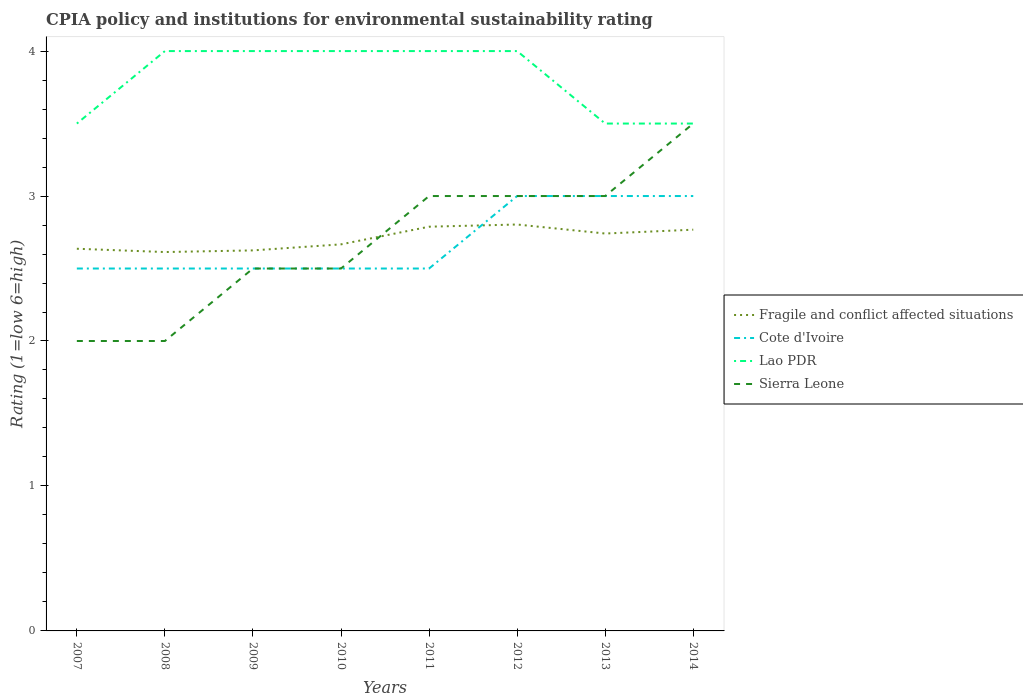Is the number of lines equal to the number of legend labels?
Your answer should be compact. Yes. Across all years, what is the maximum CPIA rating in Fragile and conflict affected situations?
Provide a short and direct response. 2.61. In which year was the CPIA rating in Fragile and conflict affected situations maximum?
Your answer should be compact. 2008. What is the total CPIA rating in Sierra Leone in the graph?
Provide a short and direct response. -0.5. What is the difference between the highest and the second highest CPIA rating in Sierra Leone?
Make the answer very short. 1.5. What is the difference between two consecutive major ticks on the Y-axis?
Offer a very short reply. 1. Are the values on the major ticks of Y-axis written in scientific E-notation?
Ensure brevity in your answer.  No. Does the graph contain any zero values?
Provide a short and direct response. No. Does the graph contain grids?
Offer a very short reply. No. Where does the legend appear in the graph?
Ensure brevity in your answer.  Center right. What is the title of the graph?
Provide a short and direct response. CPIA policy and institutions for environmental sustainability rating. Does "Pacific island small states" appear as one of the legend labels in the graph?
Make the answer very short. No. What is the label or title of the X-axis?
Ensure brevity in your answer.  Years. What is the Rating (1=low 6=high) of Fragile and conflict affected situations in 2007?
Offer a very short reply. 2.64. What is the Rating (1=low 6=high) of Fragile and conflict affected situations in 2008?
Make the answer very short. 2.61. What is the Rating (1=low 6=high) of Cote d'Ivoire in 2008?
Offer a terse response. 2.5. What is the Rating (1=low 6=high) of Lao PDR in 2008?
Provide a short and direct response. 4. What is the Rating (1=low 6=high) in Fragile and conflict affected situations in 2009?
Offer a very short reply. 2.62. What is the Rating (1=low 6=high) of Sierra Leone in 2009?
Offer a very short reply. 2.5. What is the Rating (1=low 6=high) of Fragile and conflict affected situations in 2010?
Offer a very short reply. 2.67. What is the Rating (1=low 6=high) in Fragile and conflict affected situations in 2011?
Your answer should be very brief. 2.79. What is the Rating (1=low 6=high) in Cote d'Ivoire in 2011?
Your response must be concise. 2.5. What is the Rating (1=low 6=high) in Lao PDR in 2011?
Provide a succinct answer. 4. What is the Rating (1=low 6=high) of Fragile and conflict affected situations in 2012?
Offer a very short reply. 2.8. What is the Rating (1=low 6=high) in Sierra Leone in 2012?
Give a very brief answer. 3. What is the Rating (1=low 6=high) of Fragile and conflict affected situations in 2013?
Ensure brevity in your answer.  2.74. What is the Rating (1=low 6=high) in Lao PDR in 2013?
Provide a short and direct response. 3.5. What is the Rating (1=low 6=high) of Sierra Leone in 2013?
Ensure brevity in your answer.  3. What is the Rating (1=low 6=high) in Fragile and conflict affected situations in 2014?
Make the answer very short. 2.77. What is the Rating (1=low 6=high) in Lao PDR in 2014?
Your response must be concise. 3.5. What is the Rating (1=low 6=high) in Sierra Leone in 2014?
Ensure brevity in your answer.  3.5. Across all years, what is the maximum Rating (1=low 6=high) of Fragile and conflict affected situations?
Provide a short and direct response. 2.8. Across all years, what is the maximum Rating (1=low 6=high) of Sierra Leone?
Give a very brief answer. 3.5. Across all years, what is the minimum Rating (1=low 6=high) of Fragile and conflict affected situations?
Provide a short and direct response. 2.61. Across all years, what is the minimum Rating (1=low 6=high) of Lao PDR?
Keep it short and to the point. 3.5. What is the total Rating (1=low 6=high) of Fragile and conflict affected situations in the graph?
Provide a succinct answer. 21.64. What is the total Rating (1=low 6=high) in Cote d'Ivoire in the graph?
Your response must be concise. 21.5. What is the total Rating (1=low 6=high) of Lao PDR in the graph?
Give a very brief answer. 30.5. What is the total Rating (1=low 6=high) in Sierra Leone in the graph?
Give a very brief answer. 21.5. What is the difference between the Rating (1=low 6=high) in Fragile and conflict affected situations in 2007 and that in 2008?
Give a very brief answer. 0.02. What is the difference between the Rating (1=low 6=high) of Lao PDR in 2007 and that in 2008?
Ensure brevity in your answer.  -0.5. What is the difference between the Rating (1=low 6=high) of Sierra Leone in 2007 and that in 2008?
Your answer should be compact. 0. What is the difference between the Rating (1=low 6=high) of Fragile and conflict affected situations in 2007 and that in 2009?
Keep it short and to the point. 0.01. What is the difference between the Rating (1=low 6=high) of Sierra Leone in 2007 and that in 2009?
Your response must be concise. -0.5. What is the difference between the Rating (1=low 6=high) of Fragile and conflict affected situations in 2007 and that in 2010?
Your answer should be compact. -0.03. What is the difference between the Rating (1=low 6=high) in Lao PDR in 2007 and that in 2010?
Keep it short and to the point. -0.5. What is the difference between the Rating (1=low 6=high) of Fragile and conflict affected situations in 2007 and that in 2011?
Give a very brief answer. -0.15. What is the difference between the Rating (1=low 6=high) of Cote d'Ivoire in 2007 and that in 2011?
Offer a very short reply. 0. What is the difference between the Rating (1=low 6=high) of Lao PDR in 2007 and that in 2011?
Offer a very short reply. -0.5. What is the difference between the Rating (1=low 6=high) in Sierra Leone in 2007 and that in 2011?
Keep it short and to the point. -1. What is the difference between the Rating (1=low 6=high) of Fragile and conflict affected situations in 2007 and that in 2012?
Your response must be concise. -0.17. What is the difference between the Rating (1=low 6=high) in Cote d'Ivoire in 2007 and that in 2012?
Give a very brief answer. -0.5. What is the difference between the Rating (1=low 6=high) of Sierra Leone in 2007 and that in 2012?
Your response must be concise. -1. What is the difference between the Rating (1=low 6=high) in Fragile and conflict affected situations in 2007 and that in 2013?
Make the answer very short. -0.1. What is the difference between the Rating (1=low 6=high) of Cote d'Ivoire in 2007 and that in 2013?
Your answer should be compact. -0.5. What is the difference between the Rating (1=low 6=high) of Lao PDR in 2007 and that in 2013?
Your answer should be very brief. 0. What is the difference between the Rating (1=low 6=high) of Sierra Leone in 2007 and that in 2013?
Give a very brief answer. -1. What is the difference between the Rating (1=low 6=high) in Fragile and conflict affected situations in 2007 and that in 2014?
Give a very brief answer. -0.13. What is the difference between the Rating (1=low 6=high) in Cote d'Ivoire in 2007 and that in 2014?
Provide a succinct answer. -0.5. What is the difference between the Rating (1=low 6=high) of Lao PDR in 2007 and that in 2014?
Provide a succinct answer. 0. What is the difference between the Rating (1=low 6=high) of Sierra Leone in 2007 and that in 2014?
Provide a succinct answer. -1.5. What is the difference between the Rating (1=low 6=high) in Fragile and conflict affected situations in 2008 and that in 2009?
Ensure brevity in your answer.  -0.01. What is the difference between the Rating (1=low 6=high) of Fragile and conflict affected situations in 2008 and that in 2010?
Give a very brief answer. -0.05. What is the difference between the Rating (1=low 6=high) in Cote d'Ivoire in 2008 and that in 2010?
Your answer should be very brief. 0. What is the difference between the Rating (1=low 6=high) in Fragile and conflict affected situations in 2008 and that in 2011?
Make the answer very short. -0.17. What is the difference between the Rating (1=low 6=high) of Lao PDR in 2008 and that in 2011?
Offer a terse response. 0. What is the difference between the Rating (1=low 6=high) in Fragile and conflict affected situations in 2008 and that in 2012?
Keep it short and to the point. -0.19. What is the difference between the Rating (1=low 6=high) of Cote d'Ivoire in 2008 and that in 2012?
Offer a terse response. -0.5. What is the difference between the Rating (1=low 6=high) in Fragile and conflict affected situations in 2008 and that in 2013?
Keep it short and to the point. -0.13. What is the difference between the Rating (1=low 6=high) of Lao PDR in 2008 and that in 2013?
Offer a terse response. 0.5. What is the difference between the Rating (1=low 6=high) in Sierra Leone in 2008 and that in 2013?
Offer a very short reply. -1. What is the difference between the Rating (1=low 6=high) of Fragile and conflict affected situations in 2008 and that in 2014?
Give a very brief answer. -0.15. What is the difference between the Rating (1=low 6=high) in Cote d'Ivoire in 2008 and that in 2014?
Give a very brief answer. -0.5. What is the difference between the Rating (1=low 6=high) of Lao PDR in 2008 and that in 2014?
Keep it short and to the point. 0.5. What is the difference between the Rating (1=low 6=high) in Fragile and conflict affected situations in 2009 and that in 2010?
Give a very brief answer. -0.04. What is the difference between the Rating (1=low 6=high) in Sierra Leone in 2009 and that in 2010?
Ensure brevity in your answer.  0. What is the difference between the Rating (1=low 6=high) in Fragile and conflict affected situations in 2009 and that in 2011?
Your answer should be compact. -0.16. What is the difference between the Rating (1=low 6=high) of Lao PDR in 2009 and that in 2011?
Ensure brevity in your answer.  0. What is the difference between the Rating (1=low 6=high) in Sierra Leone in 2009 and that in 2011?
Offer a very short reply. -0.5. What is the difference between the Rating (1=low 6=high) in Fragile and conflict affected situations in 2009 and that in 2012?
Offer a very short reply. -0.18. What is the difference between the Rating (1=low 6=high) in Fragile and conflict affected situations in 2009 and that in 2013?
Offer a very short reply. -0.12. What is the difference between the Rating (1=low 6=high) in Lao PDR in 2009 and that in 2013?
Ensure brevity in your answer.  0.5. What is the difference between the Rating (1=low 6=high) in Sierra Leone in 2009 and that in 2013?
Provide a short and direct response. -0.5. What is the difference between the Rating (1=low 6=high) of Fragile and conflict affected situations in 2009 and that in 2014?
Keep it short and to the point. -0.14. What is the difference between the Rating (1=low 6=high) in Lao PDR in 2009 and that in 2014?
Your answer should be compact. 0.5. What is the difference between the Rating (1=low 6=high) of Fragile and conflict affected situations in 2010 and that in 2011?
Keep it short and to the point. -0.12. What is the difference between the Rating (1=low 6=high) of Cote d'Ivoire in 2010 and that in 2011?
Keep it short and to the point. 0. What is the difference between the Rating (1=low 6=high) of Sierra Leone in 2010 and that in 2011?
Provide a succinct answer. -0.5. What is the difference between the Rating (1=low 6=high) of Fragile and conflict affected situations in 2010 and that in 2012?
Give a very brief answer. -0.14. What is the difference between the Rating (1=low 6=high) in Cote d'Ivoire in 2010 and that in 2012?
Your response must be concise. -0.5. What is the difference between the Rating (1=low 6=high) in Lao PDR in 2010 and that in 2012?
Your answer should be very brief. 0. What is the difference between the Rating (1=low 6=high) in Sierra Leone in 2010 and that in 2012?
Provide a short and direct response. -0.5. What is the difference between the Rating (1=low 6=high) of Fragile and conflict affected situations in 2010 and that in 2013?
Ensure brevity in your answer.  -0.07. What is the difference between the Rating (1=low 6=high) in Lao PDR in 2010 and that in 2013?
Ensure brevity in your answer.  0.5. What is the difference between the Rating (1=low 6=high) in Sierra Leone in 2010 and that in 2013?
Keep it short and to the point. -0.5. What is the difference between the Rating (1=low 6=high) in Fragile and conflict affected situations in 2010 and that in 2014?
Ensure brevity in your answer.  -0.1. What is the difference between the Rating (1=low 6=high) in Cote d'Ivoire in 2010 and that in 2014?
Provide a short and direct response. -0.5. What is the difference between the Rating (1=low 6=high) of Sierra Leone in 2010 and that in 2014?
Make the answer very short. -1. What is the difference between the Rating (1=low 6=high) of Fragile and conflict affected situations in 2011 and that in 2012?
Your answer should be compact. -0.02. What is the difference between the Rating (1=low 6=high) in Lao PDR in 2011 and that in 2012?
Ensure brevity in your answer.  0. What is the difference between the Rating (1=low 6=high) of Fragile and conflict affected situations in 2011 and that in 2013?
Provide a succinct answer. 0.05. What is the difference between the Rating (1=low 6=high) of Cote d'Ivoire in 2011 and that in 2013?
Your answer should be compact. -0.5. What is the difference between the Rating (1=low 6=high) in Lao PDR in 2011 and that in 2013?
Make the answer very short. 0.5. What is the difference between the Rating (1=low 6=high) in Fragile and conflict affected situations in 2011 and that in 2014?
Your answer should be compact. 0.02. What is the difference between the Rating (1=low 6=high) of Lao PDR in 2011 and that in 2014?
Give a very brief answer. 0.5. What is the difference between the Rating (1=low 6=high) in Fragile and conflict affected situations in 2012 and that in 2013?
Provide a succinct answer. 0.06. What is the difference between the Rating (1=low 6=high) in Lao PDR in 2012 and that in 2013?
Your answer should be very brief. 0.5. What is the difference between the Rating (1=low 6=high) of Fragile and conflict affected situations in 2012 and that in 2014?
Offer a very short reply. 0.04. What is the difference between the Rating (1=low 6=high) in Cote d'Ivoire in 2012 and that in 2014?
Give a very brief answer. 0. What is the difference between the Rating (1=low 6=high) of Lao PDR in 2012 and that in 2014?
Offer a terse response. 0.5. What is the difference between the Rating (1=low 6=high) in Fragile and conflict affected situations in 2013 and that in 2014?
Offer a terse response. -0.03. What is the difference between the Rating (1=low 6=high) of Cote d'Ivoire in 2013 and that in 2014?
Keep it short and to the point. 0. What is the difference between the Rating (1=low 6=high) in Lao PDR in 2013 and that in 2014?
Give a very brief answer. 0. What is the difference between the Rating (1=low 6=high) in Sierra Leone in 2013 and that in 2014?
Make the answer very short. -0.5. What is the difference between the Rating (1=low 6=high) in Fragile and conflict affected situations in 2007 and the Rating (1=low 6=high) in Cote d'Ivoire in 2008?
Provide a succinct answer. 0.14. What is the difference between the Rating (1=low 6=high) in Fragile and conflict affected situations in 2007 and the Rating (1=low 6=high) in Lao PDR in 2008?
Your response must be concise. -1.36. What is the difference between the Rating (1=low 6=high) in Fragile and conflict affected situations in 2007 and the Rating (1=low 6=high) in Sierra Leone in 2008?
Keep it short and to the point. 0.64. What is the difference between the Rating (1=low 6=high) in Cote d'Ivoire in 2007 and the Rating (1=low 6=high) in Sierra Leone in 2008?
Offer a terse response. 0.5. What is the difference between the Rating (1=low 6=high) in Fragile and conflict affected situations in 2007 and the Rating (1=low 6=high) in Cote d'Ivoire in 2009?
Your answer should be compact. 0.14. What is the difference between the Rating (1=low 6=high) in Fragile and conflict affected situations in 2007 and the Rating (1=low 6=high) in Lao PDR in 2009?
Provide a short and direct response. -1.36. What is the difference between the Rating (1=low 6=high) of Fragile and conflict affected situations in 2007 and the Rating (1=low 6=high) of Sierra Leone in 2009?
Provide a short and direct response. 0.14. What is the difference between the Rating (1=low 6=high) in Cote d'Ivoire in 2007 and the Rating (1=low 6=high) in Lao PDR in 2009?
Make the answer very short. -1.5. What is the difference between the Rating (1=low 6=high) of Cote d'Ivoire in 2007 and the Rating (1=low 6=high) of Sierra Leone in 2009?
Your answer should be compact. 0. What is the difference between the Rating (1=low 6=high) of Fragile and conflict affected situations in 2007 and the Rating (1=low 6=high) of Cote d'Ivoire in 2010?
Keep it short and to the point. 0.14. What is the difference between the Rating (1=low 6=high) of Fragile and conflict affected situations in 2007 and the Rating (1=low 6=high) of Lao PDR in 2010?
Keep it short and to the point. -1.36. What is the difference between the Rating (1=low 6=high) in Fragile and conflict affected situations in 2007 and the Rating (1=low 6=high) in Sierra Leone in 2010?
Your answer should be compact. 0.14. What is the difference between the Rating (1=low 6=high) of Cote d'Ivoire in 2007 and the Rating (1=low 6=high) of Lao PDR in 2010?
Keep it short and to the point. -1.5. What is the difference between the Rating (1=low 6=high) in Cote d'Ivoire in 2007 and the Rating (1=low 6=high) in Sierra Leone in 2010?
Your answer should be compact. 0. What is the difference between the Rating (1=low 6=high) of Fragile and conflict affected situations in 2007 and the Rating (1=low 6=high) of Cote d'Ivoire in 2011?
Keep it short and to the point. 0.14. What is the difference between the Rating (1=low 6=high) of Fragile and conflict affected situations in 2007 and the Rating (1=low 6=high) of Lao PDR in 2011?
Your response must be concise. -1.36. What is the difference between the Rating (1=low 6=high) in Fragile and conflict affected situations in 2007 and the Rating (1=low 6=high) in Sierra Leone in 2011?
Make the answer very short. -0.36. What is the difference between the Rating (1=low 6=high) of Cote d'Ivoire in 2007 and the Rating (1=low 6=high) of Lao PDR in 2011?
Provide a short and direct response. -1.5. What is the difference between the Rating (1=low 6=high) of Lao PDR in 2007 and the Rating (1=low 6=high) of Sierra Leone in 2011?
Your answer should be compact. 0.5. What is the difference between the Rating (1=low 6=high) in Fragile and conflict affected situations in 2007 and the Rating (1=low 6=high) in Cote d'Ivoire in 2012?
Offer a very short reply. -0.36. What is the difference between the Rating (1=low 6=high) in Fragile and conflict affected situations in 2007 and the Rating (1=low 6=high) in Lao PDR in 2012?
Your answer should be very brief. -1.36. What is the difference between the Rating (1=low 6=high) in Fragile and conflict affected situations in 2007 and the Rating (1=low 6=high) in Sierra Leone in 2012?
Ensure brevity in your answer.  -0.36. What is the difference between the Rating (1=low 6=high) of Fragile and conflict affected situations in 2007 and the Rating (1=low 6=high) of Cote d'Ivoire in 2013?
Give a very brief answer. -0.36. What is the difference between the Rating (1=low 6=high) in Fragile and conflict affected situations in 2007 and the Rating (1=low 6=high) in Lao PDR in 2013?
Keep it short and to the point. -0.86. What is the difference between the Rating (1=low 6=high) of Fragile and conflict affected situations in 2007 and the Rating (1=low 6=high) of Sierra Leone in 2013?
Give a very brief answer. -0.36. What is the difference between the Rating (1=low 6=high) of Cote d'Ivoire in 2007 and the Rating (1=low 6=high) of Sierra Leone in 2013?
Offer a terse response. -0.5. What is the difference between the Rating (1=low 6=high) in Fragile and conflict affected situations in 2007 and the Rating (1=low 6=high) in Cote d'Ivoire in 2014?
Your answer should be compact. -0.36. What is the difference between the Rating (1=low 6=high) in Fragile and conflict affected situations in 2007 and the Rating (1=low 6=high) in Lao PDR in 2014?
Make the answer very short. -0.86. What is the difference between the Rating (1=low 6=high) of Fragile and conflict affected situations in 2007 and the Rating (1=low 6=high) of Sierra Leone in 2014?
Provide a short and direct response. -0.86. What is the difference between the Rating (1=low 6=high) of Cote d'Ivoire in 2007 and the Rating (1=low 6=high) of Lao PDR in 2014?
Give a very brief answer. -1. What is the difference between the Rating (1=low 6=high) in Cote d'Ivoire in 2007 and the Rating (1=low 6=high) in Sierra Leone in 2014?
Your answer should be very brief. -1. What is the difference between the Rating (1=low 6=high) of Lao PDR in 2007 and the Rating (1=low 6=high) of Sierra Leone in 2014?
Your answer should be very brief. 0. What is the difference between the Rating (1=low 6=high) of Fragile and conflict affected situations in 2008 and the Rating (1=low 6=high) of Cote d'Ivoire in 2009?
Ensure brevity in your answer.  0.11. What is the difference between the Rating (1=low 6=high) of Fragile and conflict affected situations in 2008 and the Rating (1=low 6=high) of Lao PDR in 2009?
Provide a short and direct response. -1.39. What is the difference between the Rating (1=low 6=high) of Fragile and conflict affected situations in 2008 and the Rating (1=low 6=high) of Sierra Leone in 2009?
Provide a succinct answer. 0.11. What is the difference between the Rating (1=low 6=high) in Fragile and conflict affected situations in 2008 and the Rating (1=low 6=high) in Cote d'Ivoire in 2010?
Make the answer very short. 0.11. What is the difference between the Rating (1=low 6=high) in Fragile and conflict affected situations in 2008 and the Rating (1=low 6=high) in Lao PDR in 2010?
Give a very brief answer. -1.39. What is the difference between the Rating (1=low 6=high) in Fragile and conflict affected situations in 2008 and the Rating (1=low 6=high) in Sierra Leone in 2010?
Keep it short and to the point. 0.11. What is the difference between the Rating (1=low 6=high) of Fragile and conflict affected situations in 2008 and the Rating (1=low 6=high) of Cote d'Ivoire in 2011?
Give a very brief answer. 0.11. What is the difference between the Rating (1=low 6=high) of Fragile and conflict affected situations in 2008 and the Rating (1=low 6=high) of Lao PDR in 2011?
Keep it short and to the point. -1.39. What is the difference between the Rating (1=low 6=high) in Fragile and conflict affected situations in 2008 and the Rating (1=low 6=high) in Sierra Leone in 2011?
Provide a short and direct response. -0.39. What is the difference between the Rating (1=low 6=high) in Cote d'Ivoire in 2008 and the Rating (1=low 6=high) in Lao PDR in 2011?
Give a very brief answer. -1.5. What is the difference between the Rating (1=low 6=high) in Cote d'Ivoire in 2008 and the Rating (1=low 6=high) in Sierra Leone in 2011?
Offer a terse response. -0.5. What is the difference between the Rating (1=low 6=high) of Fragile and conflict affected situations in 2008 and the Rating (1=low 6=high) of Cote d'Ivoire in 2012?
Your answer should be very brief. -0.39. What is the difference between the Rating (1=low 6=high) of Fragile and conflict affected situations in 2008 and the Rating (1=low 6=high) of Lao PDR in 2012?
Your answer should be very brief. -1.39. What is the difference between the Rating (1=low 6=high) in Fragile and conflict affected situations in 2008 and the Rating (1=low 6=high) in Sierra Leone in 2012?
Your answer should be compact. -0.39. What is the difference between the Rating (1=low 6=high) of Cote d'Ivoire in 2008 and the Rating (1=low 6=high) of Lao PDR in 2012?
Offer a very short reply. -1.5. What is the difference between the Rating (1=low 6=high) of Lao PDR in 2008 and the Rating (1=low 6=high) of Sierra Leone in 2012?
Offer a terse response. 1. What is the difference between the Rating (1=low 6=high) in Fragile and conflict affected situations in 2008 and the Rating (1=low 6=high) in Cote d'Ivoire in 2013?
Your answer should be very brief. -0.39. What is the difference between the Rating (1=low 6=high) of Fragile and conflict affected situations in 2008 and the Rating (1=low 6=high) of Lao PDR in 2013?
Keep it short and to the point. -0.89. What is the difference between the Rating (1=low 6=high) of Fragile and conflict affected situations in 2008 and the Rating (1=low 6=high) of Sierra Leone in 2013?
Make the answer very short. -0.39. What is the difference between the Rating (1=low 6=high) in Cote d'Ivoire in 2008 and the Rating (1=low 6=high) in Lao PDR in 2013?
Provide a short and direct response. -1. What is the difference between the Rating (1=low 6=high) in Cote d'Ivoire in 2008 and the Rating (1=low 6=high) in Sierra Leone in 2013?
Make the answer very short. -0.5. What is the difference between the Rating (1=low 6=high) of Fragile and conflict affected situations in 2008 and the Rating (1=low 6=high) of Cote d'Ivoire in 2014?
Your answer should be compact. -0.39. What is the difference between the Rating (1=low 6=high) in Fragile and conflict affected situations in 2008 and the Rating (1=low 6=high) in Lao PDR in 2014?
Your answer should be very brief. -0.89. What is the difference between the Rating (1=low 6=high) of Fragile and conflict affected situations in 2008 and the Rating (1=low 6=high) of Sierra Leone in 2014?
Your answer should be compact. -0.89. What is the difference between the Rating (1=low 6=high) in Cote d'Ivoire in 2008 and the Rating (1=low 6=high) in Lao PDR in 2014?
Your response must be concise. -1. What is the difference between the Rating (1=low 6=high) of Fragile and conflict affected situations in 2009 and the Rating (1=low 6=high) of Cote d'Ivoire in 2010?
Provide a succinct answer. 0.12. What is the difference between the Rating (1=low 6=high) in Fragile and conflict affected situations in 2009 and the Rating (1=low 6=high) in Lao PDR in 2010?
Your answer should be very brief. -1.38. What is the difference between the Rating (1=low 6=high) of Cote d'Ivoire in 2009 and the Rating (1=low 6=high) of Lao PDR in 2010?
Ensure brevity in your answer.  -1.5. What is the difference between the Rating (1=low 6=high) of Fragile and conflict affected situations in 2009 and the Rating (1=low 6=high) of Cote d'Ivoire in 2011?
Provide a short and direct response. 0.12. What is the difference between the Rating (1=low 6=high) of Fragile and conflict affected situations in 2009 and the Rating (1=low 6=high) of Lao PDR in 2011?
Ensure brevity in your answer.  -1.38. What is the difference between the Rating (1=low 6=high) of Fragile and conflict affected situations in 2009 and the Rating (1=low 6=high) of Sierra Leone in 2011?
Give a very brief answer. -0.38. What is the difference between the Rating (1=low 6=high) of Cote d'Ivoire in 2009 and the Rating (1=low 6=high) of Sierra Leone in 2011?
Your answer should be very brief. -0.5. What is the difference between the Rating (1=low 6=high) of Lao PDR in 2009 and the Rating (1=low 6=high) of Sierra Leone in 2011?
Provide a short and direct response. 1. What is the difference between the Rating (1=low 6=high) in Fragile and conflict affected situations in 2009 and the Rating (1=low 6=high) in Cote d'Ivoire in 2012?
Your response must be concise. -0.38. What is the difference between the Rating (1=low 6=high) of Fragile and conflict affected situations in 2009 and the Rating (1=low 6=high) of Lao PDR in 2012?
Provide a short and direct response. -1.38. What is the difference between the Rating (1=low 6=high) in Fragile and conflict affected situations in 2009 and the Rating (1=low 6=high) in Sierra Leone in 2012?
Provide a succinct answer. -0.38. What is the difference between the Rating (1=low 6=high) of Cote d'Ivoire in 2009 and the Rating (1=low 6=high) of Lao PDR in 2012?
Ensure brevity in your answer.  -1.5. What is the difference between the Rating (1=low 6=high) in Lao PDR in 2009 and the Rating (1=low 6=high) in Sierra Leone in 2012?
Your response must be concise. 1. What is the difference between the Rating (1=low 6=high) in Fragile and conflict affected situations in 2009 and the Rating (1=low 6=high) in Cote d'Ivoire in 2013?
Keep it short and to the point. -0.38. What is the difference between the Rating (1=low 6=high) of Fragile and conflict affected situations in 2009 and the Rating (1=low 6=high) of Lao PDR in 2013?
Provide a short and direct response. -0.88. What is the difference between the Rating (1=low 6=high) of Fragile and conflict affected situations in 2009 and the Rating (1=low 6=high) of Sierra Leone in 2013?
Offer a very short reply. -0.38. What is the difference between the Rating (1=low 6=high) of Lao PDR in 2009 and the Rating (1=low 6=high) of Sierra Leone in 2013?
Your answer should be very brief. 1. What is the difference between the Rating (1=low 6=high) in Fragile and conflict affected situations in 2009 and the Rating (1=low 6=high) in Cote d'Ivoire in 2014?
Provide a short and direct response. -0.38. What is the difference between the Rating (1=low 6=high) of Fragile and conflict affected situations in 2009 and the Rating (1=low 6=high) of Lao PDR in 2014?
Ensure brevity in your answer.  -0.88. What is the difference between the Rating (1=low 6=high) of Fragile and conflict affected situations in 2009 and the Rating (1=low 6=high) of Sierra Leone in 2014?
Your response must be concise. -0.88. What is the difference between the Rating (1=low 6=high) of Cote d'Ivoire in 2009 and the Rating (1=low 6=high) of Sierra Leone in 2014?
Keep it short and to the point. -1. What is the difference between the Rating (1=low 6=high) in Lao PDR in 2009 and the Rating (1=low 6=high) in Sierra Leone in 2014?
Provide a succinct answer. 0.5. What is the difference between the Rating (1=low 6=high) in Fragile and conflict affected situations in 2010 and the Rating (1=low 6=high) in Lao PDR in 2011?
Your response must be concise. -1.33. What is the difference between the Rating (1=low 6=high) of Cote d'Ivoire in 2010 and the Rating (1=low 6=high) of Sierra Leone in 2011?
Your answer should be very brief. -0.5. What is the difference between the Rating (1=low 6=high) in Fragile and conflict affected situations in 2010 and the Rating (1=low 6=high) in Lao PDR in 2012?
Provide a succinct answer. -1.33. What is the difference between the Rating (1=low 6=high) in Fragile and conflict affected situations in 2010 and the Rating (1=low 6=high) in Sierra Leone in 2012?
Make the answer very short. -0.33. What is the difference between the Rating (1=low 6=high) of Cote d'Ivoire in 2010 and the Rating (1=low 6=high) of Sierra Leone in 2012?
Keep it short and to the point. -0.5. What is the difference between the Rating (1=low 6=high) of Cote d'Ivoire in 2010 and the Rating (1=low 6=high) of Lao PDR in 2013?
Ensure brevity in your answer.  -1. What is the difference between the Rating (1=low 6=high) of Fragile and conflict affected situations in 2010 and the Rating (1=low 6=high) of Lao PDR in 2014?
Your response must be concise. -0.83. What is the difference between the Rating (1=low 6=high) in Fragile and conflict affected situations in 2010 and the Rating (1=low 6=high) in Sierra Leone in 2014?
Make the answer very short. -0.83. What is the difference between the Rating (1=low 6=high) in Cote d'Ivoire in 2010 and the Rating (1=low 6=high) in Lao PDR in 2014?
Provide a succinct answer. -1. What is the difference between the Rating (1=low 6=high) of Lao PDR in 2010 and the Rating (1=low 6=high) of Sierra Leone in 2014?
Provide a short and direct response. 0.5. What is the difference between the Rating (1=low 6=high) of Fragile and conflict affected situations in 2011 and the Rating (1=low 6=high) of Cote d'Ivoire in 2012?
Offer a very short reply. -0.21. What is the difference between the Rating (1=low 6=high) of Fragile and conflict affected situations in 2011 and the Rating (1=low 6=high) of Lao PDR in 2012?
Offer a terse response. -1.21. What is the difference between the Rating (1=low 6=high) in Fragile and conflict affected situations in 2011 and the Rating (1=low 6=high) in Sierra Leone in 2012?
Your answer should be compact. -0.21. What is the difference between the Rating (1=low 6=high) in Fragile and conflict affected situations in 2011 and the Rating (1=low 6=high) in Cote d'Ivoire in 2013?
Offer a very short reply. -0.21. What is the difference between the Rating (1=low 6=high) in Fragile and conflict affected situations in 2011 and the Rating (1=low 6=high) in Lao PDR in 2013?
Offer a terse response. -0.71. What is the difference between the Rating (1=low 6=high) of Fragile and conflict affected situations in 2011 and the Rating (1=low 6=high) of Sierra Leone in 2013?
Your response must be concise. -0.21. What is the difference between the Rating (1=low 6=high) of Cote d'Ivoire in 2011 and the Rating (1=low 6=high) of Sierra Leone in 2013?
Keep it short and to the point. -0.5. What is the difference between the Rating (1=low 6=high) in Fragile and conflict affected situations in 2011 and the Rating (1=low 6=high) in Cote d'Ivoire in 2014?
Offer a very short reply. -0.21. What is the difference between the Rating (1=low 6=high) in Fragile and conflict affected situations in 2011 and the Rating (1=low 6=high) in Lao PDR in 2014?
Your response must be concise. -0.71. What is the difference between the Rating (1=low 6=high) of Fragile and conflict affected situations in 2011 and the Rating (1=low 6=high) of Sierra Leone in 2014?
Make the answer very short. -0.71. What is the difference between the Rating (1=low 6=high) in Cote d'Ivoire in 2011 and the Rating (1=low 6=high) in Sierra Leone in 2014?
Your answer should be very brief. -1. What is the difference between the Rating (1=low 6=high) in Fragile and conflict affected situations in 2012 and the Rating (1=low 6=high) in Cote d'Ivoire in 2013?
Make the answer very short. -0.2. What is the difference between the Rating (1=low 6=high) of Fragile and conflict affected situations in 2012 and the Rating (1=low 6=high) of Lao PDR in 2013?
Provide a succinct answer. -0.7. What is the difference between the Rating (1=low 6=high) of Fragile and conflict affected situations in 2012 and the Rating (1=low 6=high) of Sierra Leone in 2013?
Ensure brevity in your answer.  -0.2. What is the difference between the Rating (1=low 6=high) of Lao PDR in 2012 and the Rating (1=low 6=high) of Sierra Leone in 2013?
Provide a succinct answer. 1. What is the difference between the Rating (1=low 6=high) of Fragile and conflict affected situations in 2012 and the Rating (1=low 6=high) of Cote d'Ivoire in 2014?
Offer a terse response. -0.2. What is the difference between the Rating (1=low 6=high) of Fragile and conflict affected situations in 2012 and the Rating (1=low 6=high) of Lao PDR in 2014?
Keep it short and to the point. -0.7. What is the difference between the Rating (1=low 6=high) in Fragile and conflict affected situations in 2012 and the Rating (1=low 6=high) in Sierra Leone in 2014?
Make the answer very short. -0.7. What is the difference between the Rating (1=low 6=high) of Fragile and conflict affected situations in 2013 and the Rating (1=low 6=high) of Cote d'Ivoire in 2014?
Give a very brief answer. -0.26. What is the difference between the Rating (1=low 6=high) of Fragile and conflict affected situations in 2013 and the Rating (1=low 6=high) of Lao PDR in 2014?
Give a very brief answer. -0.76. What is the difference between the Rating (1=low 6=high) in Fragile and conflict affected situations in 2013 and the Rating (1=low 6=high) in Sierra Leone in 2014?
Keep it short and to the point. -0.76. What is the difference between the Rating (1=low 6=high) of Cote d'Ivoire in 2013 and the Rating (1=low 6=high) of Sierra Leone in 2014?
Offer a terse response. -0.5. What is the difference between the Rating (1=low 6=high) in Lao PDR in 2013 and the Rating (1=low 6=high) in Sierra Leone in 2014?
Offer a terse response. 0. What is the average Rating (1=low 6=high) in Fragile and conflict affected situations per year?
Keep it short and to the point. 2.71. What is the average Rating (1=low 6=high) of Cote d'Ivoire per year?
Your answer should be very brief. 2.69. What is the average Rating (1=low 6=high) of Lao PDR per year?
Make the answer very short. 3.81. What is the average Rating (1=low 6=high) in Sierra Leone per year?
Your answer should be very brief. 2.69. In the year 2007, what is the difference between the Rating (1=low 6=high) in Fragile and conflict affected situations and Rating (1=low 6=high) in Cote d'Ivoire?
Offer a very short reply. 0.14. In the year 2007, what is the difference between the Rating (1=low 6=high) of Fragile and conflict affected situations and Rating (1=low 6=high) of Lao PDR?
Ensure brevity in your answer.  -0.86. In the year 2007, what is the difference between the Rating (1=low 6=high) of Fragile and conflict affected situations and Rating (1=low 6=high) of Sierra Leone?
Ensure brevity in your answer.  0.64. In the year 2007, what is the difference between the Rating (1=low 6=high) of Cote d'Ivoire and Rating (1=low 6=high) of Sierra Leone?
Your response must be concise. 0.5. In the year 2007, what is the difference between the Rating (1=low 6=high) of Lao PDR and Rating (1=low 6=high) of Sierra Leone?
Give a very brief answer. 1.5. In the year 2008, what is the difference between the Rating (1=low 6=high) of Fragile and conflict affected situations and Rating (1=low 6=high) of Cote d'Ivoire?
Ensure brevity in your answer.  0.11. In the year 2008, what is the difference between the Rating (1=low 6=high) of Fragile and conflict affected situations and Rating (1=low 6=high) of Lao PDR?
Ensure brevity in your answer.  -1.39. In the year 2008, what is the difference between the Rating (1=low 6=high) in Fragile and conflict affected situations and Rating (1=low 6=high) in Sierra Leone?
Provide a short and direct response. 0.61. In the year 2008, what is the difference between the Rating (1=low 6=high) of Cote d'Ivoire and Rating (1=low 6=high) of Sierra Leone?
Make the answer very short. 0.5. In the year 2009, what is the difference between the Rating (1=low 6=high) of Fragile and conflict affected situations and Rating (1=low 6=high) of Cote d'Ivoire?
Provide a short and direct response. 0.12. In the year 2009, what is the difference between the Rating (1=low 6=high) of Fragile and conflict affected situations and Rating (1=low 6=high) of Lao PDR?
Provide a succinct answer. -1.38. In the year 2009, what is the difference between the Rating (1=low 6=high) of Cote d'Ivoire and Rating (1=low 6=high) of Lao PDR?
Your answer should be very brief. -1.5. In the year 2009, what is the difference between the Rating (1=low 6=high) of Cote d'Ivoire and Rating (1=low 6=high) of Sierra Leone?
Make the answer very short. 0. In the year 2009, what is the difference between the Rating (1=low 6=high) in Lao PDR and Rating (1=low 6=high) in Sierra Leone?
Give a very brief answer. 1.5. In the year 2010, what is the difference between the Rating (1=low 6=high) in Fragile and conflict affected situations and Rating (1=low 6=high) in Cote d'Ivoire?
Offer a terse response. 0.17. In the year 2010, what is the difference between the Rating (1=low 6=high) of Fragile and conflict affected situations and Rating (1=low 6=high) of Lao PDR?
Give a very brief answer. -1.33. In the year 2010, what is the difference between the Rating (1=low 6=high) of Fragile and conflict affected situations and Rating (1=low 6=high) of Sierra Leone?
Keep it short and to the point. 0.17. In the year 2011, what is the difference between the Rating (1=low 6=high) of Fragile and conflict affected situations and Rating (1=low 6=high) of Cote d'Ivoire?
Provide a short and direct response. 0.29. In the year 2011, what is the difference between the Rating (1=low 6=high) of Fragile and conflict affected situations and Rating (1=low 6=high) of Lao PDR?
Your answer should be compact. -1.21. In the year 2011, what is the difference between the Rating (1=low 6=high) in Fragile and conflict affected situations and Rating (1=low 6=high) in Sierra Leone?
Offer a terse response. -0.21. In the year 2012, what is the difference between the Rating (1=low 6=high) of Fragile and conflict affected situations and Rating (1=low 6=high) of Cote d'Ivoire?
Your answer should be compact. -0.2. In the year 2012, what is the difference between the Rating (1=low 6=high) of Fragile and conflict affected situations and Rating (1=low 6=high) of Lao PDR?
Give a very brief answer. -1.2. In the year 2012, what is the difference between the Rating (1=low 6=high) of Fragile and conflict affected situations and Rating (1=low 6=high) of Sierra Leone?
Your response must be concise. -0.2. In the year 2012, what is the difference between the Rating (1=low 6=high) in Lao PDR and Rating (1=low 6=high) in Sierra Leone?
Your response must be concise. 1. In the year 2013, what is the difference between the Rating (1=low 6=high) of Fragile and conflict affected situations and Rating (1=low 6=high) of Cote d'Ivoire?
Your answer should be compact. -0.26. In the year 2013, what is the difference between the Rating (1=low 6=high) of Fragile and conflict affected situations and Rating (1=low 6=high) of Lao PDR?
Provide a succinct answer. -0.76. In the year 2013, what is the difference between the Rating (1=low 6=high) in Fragile and conflict affected situations and Rating (1=low 6=high) in Sierra Leone?
Your response must be concise. -0.26. In the year 2013, what is the difference between the Rating (1=low 6=high) of Lao PDR and Rating (1=low 6=high) of Sierra Leone?
Keep it short and to the point. 0.5. In the year 2014, what is the difference between the Rating (1=low 6=high) in Fragile and conflict affected situations and Rating (1=low 6=high) in Cote d'Ivoire?
Your answer should be very brief. -0.23. In the year 2014, what is the difference between the Rating (1=low 6=high) of Fragile and conflict affected situations and Rating (1=low 6=high) of Lao PDR?
Your answer should be very brief. -0.73. In the year 2014, what is the difference between the Rating (1=low 6=high) in Fragile and conflict affected situations and Rating (1=low 6=high) in Sierra Leone?
Offer a terse response. -0.73. In the year 2014, what is the difference between the Rating (1=low 6=high) in Cote d'Ivoire and Rating (1=low 6=high) in Lao PDR?
Your answer should be very brief. -0.5. What is the ratio of the Rating (1=low 6=high) in Fragile and conflict affected situations in 2007 to that in 2008?
Your response must be concise. 1.01. What is the ratio of the Rating (1=low 6=high) of Sierra Leone in 2007 to that in 2008?
Provide a succinct answer. 1. What is the ratio of the Rating (1=low 6=high) of Cote d'Ivoire in 2007 to that in 2009?
Give a very brief answer. 1. What is the ratio of the Rating (1=low 6=high) of Lao PDR in 2007 to that in 2009?
Your response must be concise. 0.88. What is the ratio of the Rating (1=low 6=high) of Fragile and conflict affected situations in 2007 to that in 2010?
Provide a succinct answer. 0.99. What is the ratio of the Rating (1=low 6=high) of Fragile and conflict affected situations in 2007 to that in 2011?
Offer a terse response. 0.95. What is the ratio of the Rating (1=low 6=high) in Lao PDR in 2007 to that in 2011?
Your answer should be compact. 0.88. What is the ratio of the Rating (1=low 6=high) of Fragile and conflict affected situations in 2007 to that in 2012?
Provide a succinct answer. 0.94. What is the ratio of the Rating (1=low 6=high) in Cote d'Ivoire in 2007 to that in 2012?
Offer a very short reply. 0.83. What is the ratio of the Rating (1=low 6=high) in Sierra Leone in 2007 to that in 2012?
Keep it short and to the point. 0.67. What is the ratio of the Rating (1=low 6=high) of Fragile and conflict affected situations in 2007 to that in 2013?
Ensure brevity in your answer.  0.96. What is the ratio of the Rating (1=low 6=high) in Cote d'Ivoire in 2007 to that in 2013?
Your response must be concise. 0.83. What is the ratio of the Rating (1=low 6=high) of Fragile and conflict affected situations in 2007 to that in 2014?
Your answer should be compact. 0.95. What is the ratio of the Rating (1=low 6=high) in Lao PDR in 2007 to that in 2014?
Offer a very short reply. 1. What is the ratio of the Rating (1=low 6=high) in Cote d'Ivoire in 2008 to that in 2009?
Offer a terse response. 1. What is the ratio of the Rating (1=low 6=high) in Fragile and conflict affected situations in 2008 to that in 2010?
Your answer should be compact. 0.98. What is the ratio of the Rating (1=low 6=high) in Lao PDR in 2008 to that in 2010?
Keep it short and to the point. 1. What is the ratio of the Rating (1=low 6=high) of Fragile and conflict affected situations in 2008 to that in 2011?
Provide a short and direct response. 0.94. What is the ratio of the Rating (1=low 6=high) in Cote d'Ivoire in 2008 to that in 2011?
Your answer should be very brief. 1. What is the ratio of the Rating (1=low 6=high) of Lao PDR in 2008 to that in 2011?
Offer a terse response. 1. What is the ratio of the Rating (1=low 6=high) in Sierra Leone in 2008 to that in 2011?
Provide a succinct answer. 0.67. What is the ratio of the Rating (1=low 6=high) in Fragile and conflict affected situations in 2008 to that in 2012?
Your response must be concise. 0.93. What is the ratio of the Rating (1=low 6=high) of Fragile and conflict affected situations in 2008 to that in 2013?
Your response must be concise. 0.95. What is the ratio of the Rating (1=low 6=high) in Fragile and conflict affected situations in 2008 to that in 2014?
Your response must be concise. 0.94. What is the ratio of the Rating (1=low 6=high) in Fragile and conflict affected situations in 2009 to that in 2010?
Offer a terse response. 0.98. What is the ratio of the Rating (1=low 6=high) in Cote d'Ivoire in 2009 to that in 2010?
Make the answer very short. 1. What is the ratio of the Rating (1=low 6=high) in Lao PDR in 2009 to that in 2010?
Provide a short and direct response. 1. What is the ratio of the Rating (1=low 6=high) in Fragile and conflict affected situations in 2009 to that in 2011?
Keep it short and to the point. 0.94. What is the ratio of the Rating (1=low 6=high) in Sierra Leone in 2009 to that in 2011?
Ensure brevity in your answer.  0.83. What is the ratio of the Rating (1=low 6=high) of Fragile and conflict affected situations in 2009 to that in 2012?
Keep it short and to the point. 0.94. What is the ratio of the Rating (1=low 6=high) of Lao PDR in 2009 to that in 2012?
Offer a very short reply. 1. What is the ratio of the Rating (1=low 6=high) in Sierra Leone in 2009 to that in 2012?
Your answer should be very brief. 0.83. What is the ratio of the Rating (1=low 6=high) of Fragile and conflict affected situations in 2009 to that in 2013?
Give a very brief answer. 0.96. What is the ratio of the Rating (1=low 6=high) in Cote d'Ivoire in 2009 to that in 2013?
Give a very brief answer. 0.83. What is the ratio of the Rating (1=low 6=high) of Lao PDR in 2009 to that in 2013?
Make the answer very short. 1.14. What is the ratio of the Rating (1=low 6=high) in Sierra Leone in 2009 to that in 2013?
Make the answer very short. 0.83. What is the ratio of the Rating (1=low 6=high) of Fragile and conflict affected situations in 2009 to that in 2014?
Your response must be concise. 0.95. What is the ratio of the Rating (1=low 6=high) of Fragile and conflict affected situations in 2010 to that in 2011?
Keep it short and to the point. 0.96. What is the ratio of the Rating (1=low 6=high) of Cote d'Ivoire in 2010 to that in 2011?
Offer a very short reply. 1. What is the ratio of the Rating (1=low 6=high) of Fragile and conflict affected situations in 2010 to that in 2012?
Your answer should be compact. 0.95. What is the ratio of the Rating (1=low 6=high) in Cote d'Ivoire in 2010 to that in 2012?
Offer a very short reply. 0.83. What is the ratio of the Rating (1=low 6=high) in Lao PDR in 2010 to that in 2012?
Make the answer very short. 1. What is the ratio of the Rating (1=low 6=high) of Fragile and conflict affected situations in 2010 to that in 2013?
Make the answer very short. 0.97. What is the ratio of the Rating (1=low 6=high) of Cote d'Ivoire in 2010 to that in 2013?
Offer a very short reply. 0.83. What is the ratio of the Rating (1=low 6=high) in Fragile and conflict affected situations in 2010 to that in 2014?
Offer a very short reply. 0.96. What is the ratio of the Rating (1=low 6=high) in Lao PDR in 2010 to that in 2014?
Offer a terse response. 1.14. What is the ratio of the Rating (1=low 6=high) in Sierra Leone in 2010 to that in 2014?
Your response must be concise. 0.71. What is the ratio of the Rating (1=low 6=high) of Sierra Leone in 2011 to that in 2012?
Your answer should be compact. 1. What is the ratio of the Rating (1=low 6=high) of Fragile and conflict affected situations in 2011 to that in 2013?
Your answer should be compact. 1.02. What is the ratio of the Rating (1=low 6=high) in Sierra Leone in 2011 to that in 2013?
Make the answer very short. 1. What is the ratio of the Rating (1=low 6=high) in Fragile and conflict affected situations in 2011 to that in 2014?
Offer a terse response. 1.01. What is the ratio of the Rating (1=low 6=high) in Sierra Leone in 2011 to that in 2014?
Provide a short and direct response. 0.86. What is the ratio of the Rating (1=low 6=high) in Fragile and conflict affected situations in 2012 to that in 2013?
Ensure brevity in your answer.  1.02. What is the ratio of the Rating (1=low 6=high) in Cote d'Ivoire in 2012 to that in 2013?
Provide a succinct answer. 1. What is the ratio of the Rating (1=low 6=high) of Sierra Leone in 2012 to that in 2013?
Your answer should be very brief. 1. What is the ratio of the Rating (1=low 6=high) of Fragile and conflict affected situations in 2012 to that in 2014?
Your answer should be compact. 1.01. What is the ratio of the Rating (1=low 6=high) of Sierra Leone in 2013 to that in 2014?
Keep it short and to the point. 0.86. What is the difference between the highest and the second highest Rating (1=low 6=high) in Fragile and conflict affected situations?
Provide a succinct answer. 0.02. What is the difference between the highest and the second highest Rating (1=low 6=high) of Sierra Leone?
Your answer should be very brief. 0.5. What is the difference between the highest and the lowest Rating (1=low 6=high) in Fragile and conflict affected situations?
Make the answer very short. 0.19. What is the difference between the highest and the lowest Rating (1=low 6=high) in Lao PDR?
Your answer should be very brief. 0.5. What is the difference between the highest and the lowest Rating (1=low 6=high) in Sierra Leone?
Your answer should be very brief. 1.5. 